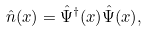<formula> <loc_0><loc_0><loc_500><loc_500>\hat { n } ( { x } ) = \hat { \Psi } ^ { \dag } ( { x } ) \hat { \Psi } ( { x } ) ,</formula> 